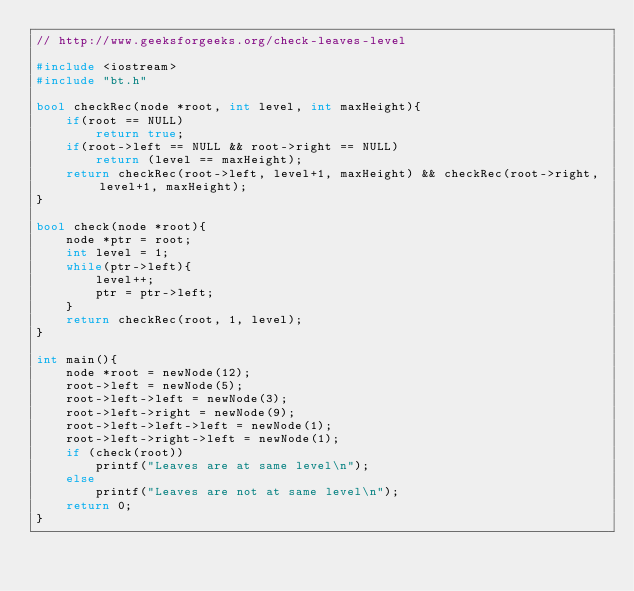<code> <loc_0><loc_0><loc_500><loc_500><_C++_>// http://www.geeksforgeeks.org/check-leaves-level

#include <iostream>
#include "bt.h"

bool checkRec(node *root, int level, int maxHeight){
	if(root == NULL)
		return true;
	if(root->left == NULL && root->right == NULL)
		return (level == maxHeight);
	return checkRec(root->left, level+1, maxHeight) && checkRec(root->right, level+1, maxHeight);
}

bool check(node *root){
	node *ptr = root;
	int level = 1;
	while(ptr->left){
		level++;
		ptr = ptr->left;
	}
	return checkRec(root, 1, level);
}

int main(){
	node *root = newNode(12);
    root->left = newNode(5);
    root->left->left = newNode(3);
    root->left->right = newNode(9);
    root->left->left->left = newNode(1);
    root->left->right->left = newNode(1);
    if (check(root))
        printf("Leaves are at same level\n");
    else
        printf("Leaves are not at same level\n");
	return 0;
}

</code> 